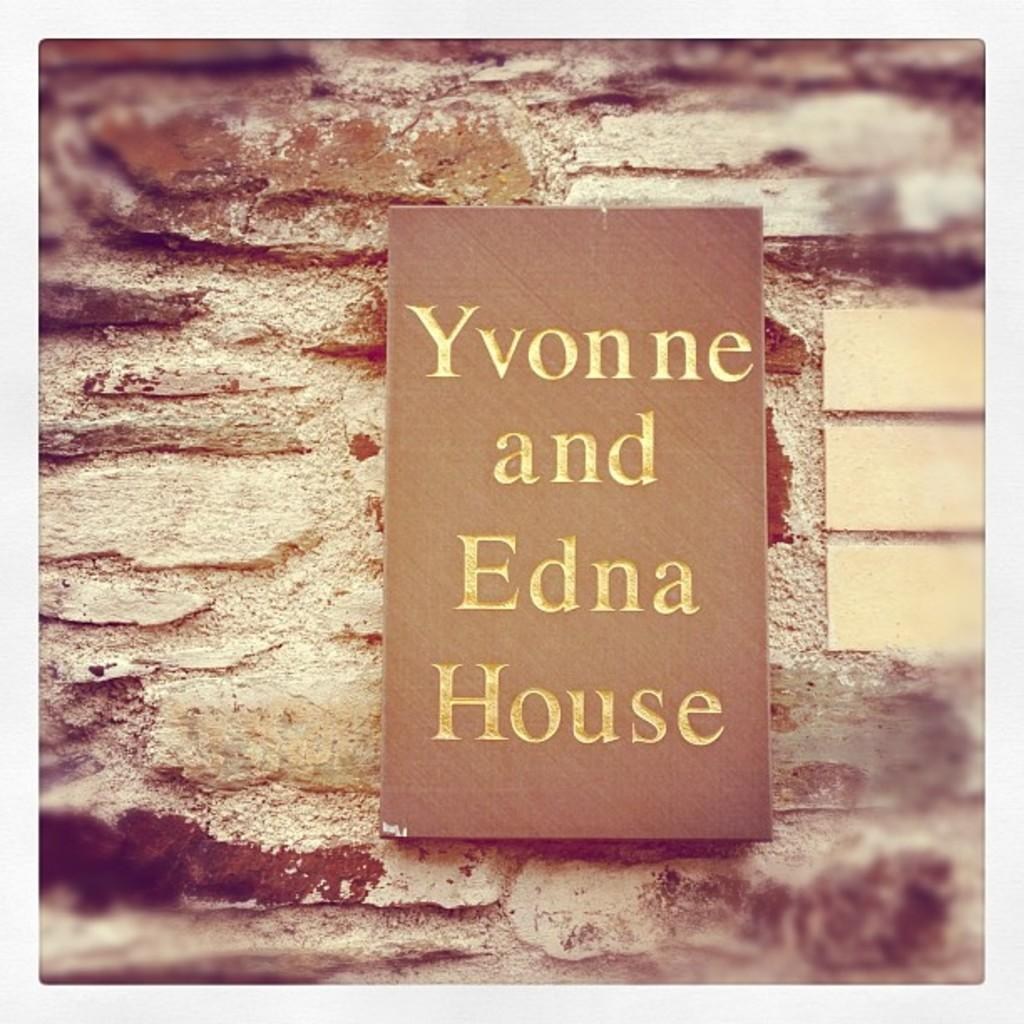<image>
Relay a brief, clear account of the picture shown. A sign outside a house called Yvonne and Edna house 